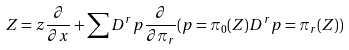<formula> <loc_0><loc_0><loc_500><loc_500>Z = z \frac { \partial } { \partial x } + \sum D ^ { r } p \frac { \partial } { \partial \pi _ { r } } ( p = \pi _ { 0 } ( Z ) D ^ { r } p = \pi _ { r } ( Z ) )</formula> 